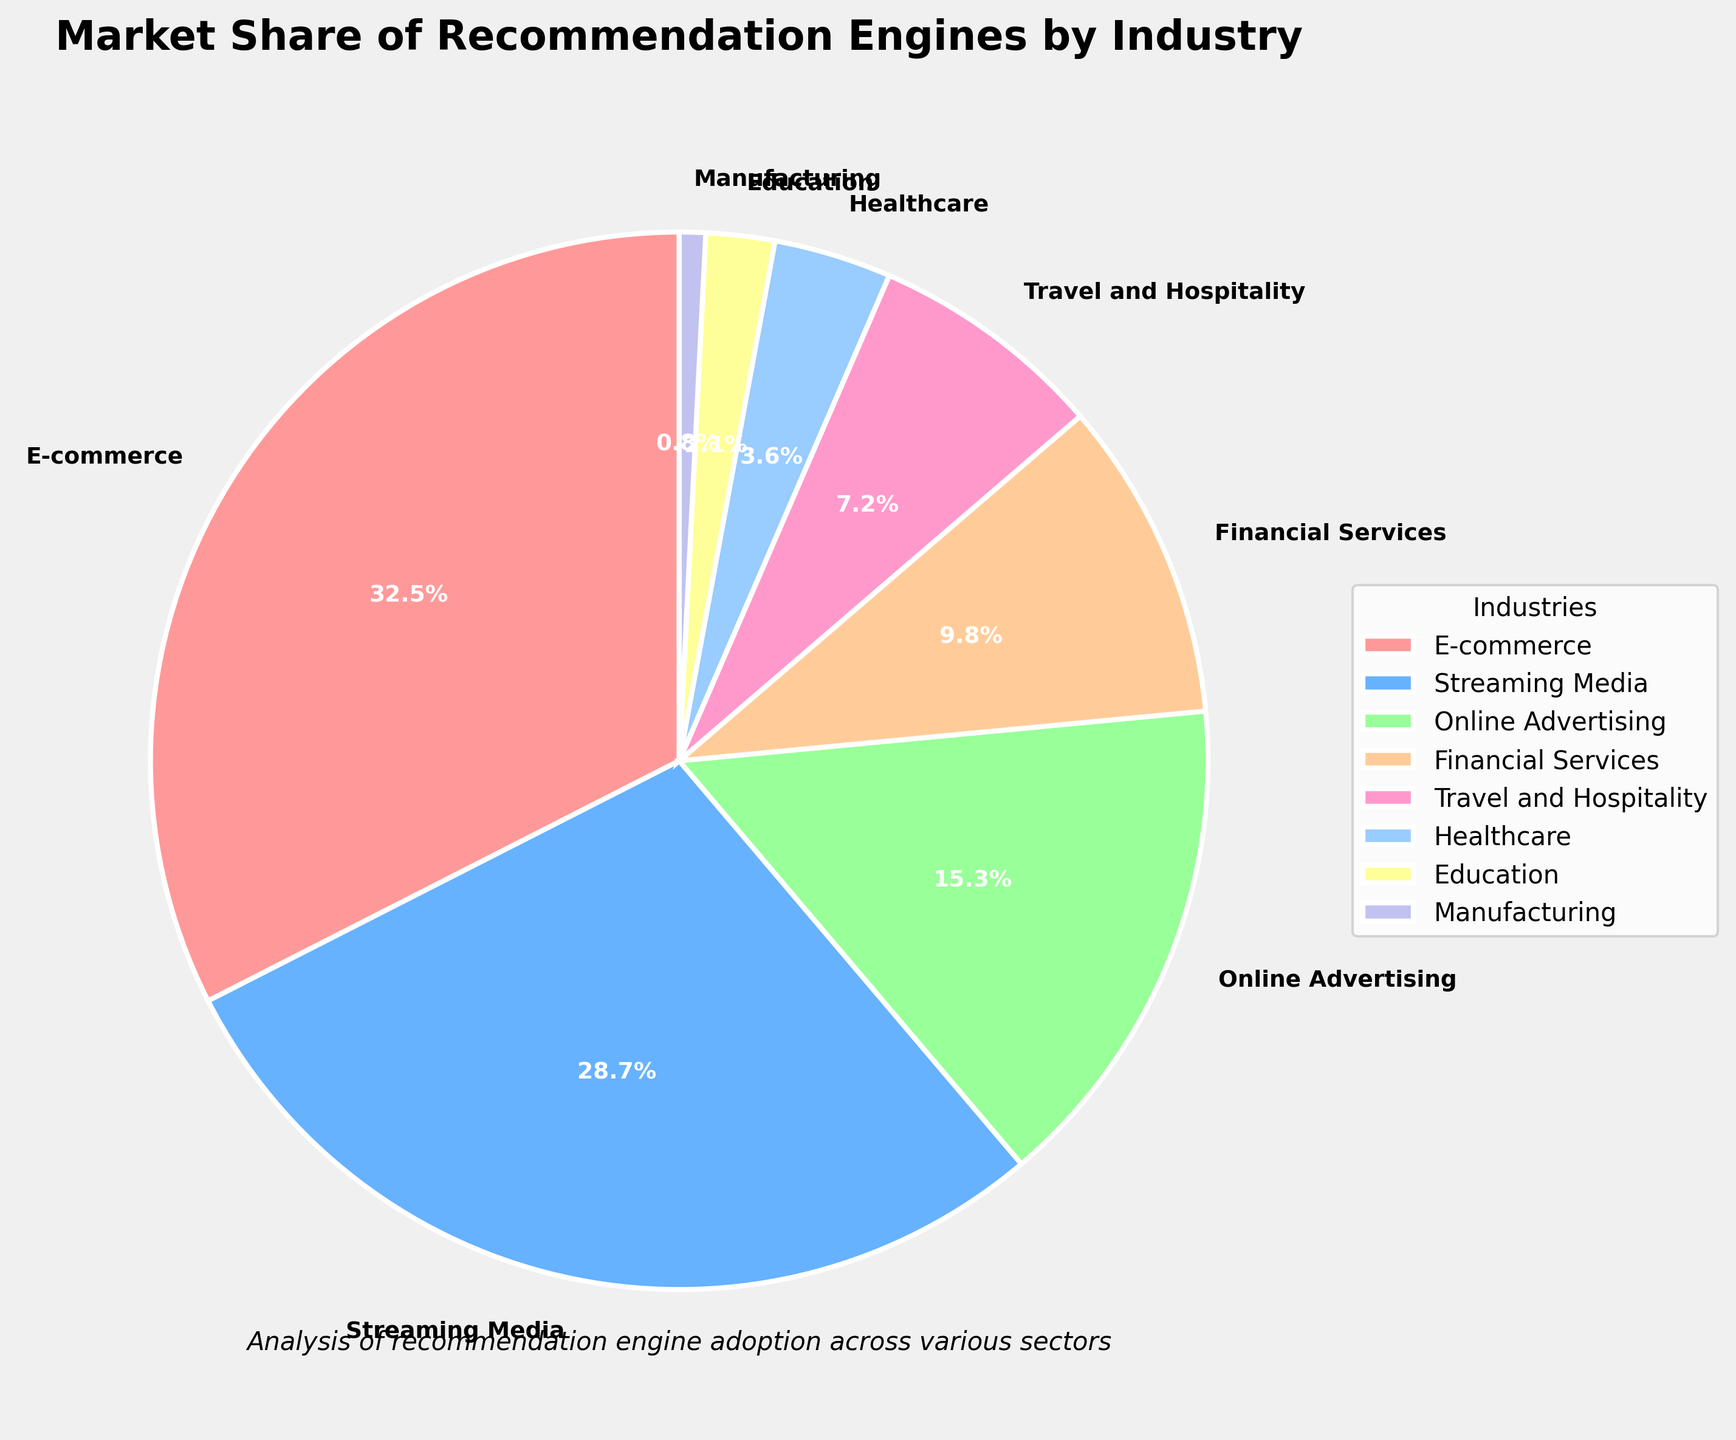Which industry has the highest market share for recommendation engines? By examining the largest segment in the pie chart, we see that the "E-commerce" industry has the highest market share of 32.5%.
Answer: E-commerce Which two industries combined have approximately 45% of the market share? "E-commerce" has 32.5% and "Financial Services" has 9.8%. Summing these, 32.5% + 9.8% = 42.3%, which is close to 45%.
Answer: E-commerce and Financial Services What is the difference in market share between the Streaming Media and Healthcare industries? The market share for "Streaming Media" is 28.7% and for "Healthcare" is 3.6%. The difference is 28.7% - 3.6% = 25.1%.
Answer: 25.1% Which industry has a market share between 5% and 10%? By inspecting the pie chart, "Travel and Hospitality" has a market share of 7.2%, which falls between 5% and 10%.
Answer: Travel and Hospitality Which industry occupies the smallest segment in the pie chart? The smallest segment in the pie chart represents the "Manufacturing" industry with a market share of 0.8%.
Answer: Manufacturing What is the total market share for industries that have less than 10% market share each? The industries are "Financial Services" with 9.8%, "Travel and Hospitality" with 7.2%, "Healthcare" with 3.6%, "Education" with 2.1%, and "Manufacturing" with 0.8%. Adding them up, 9.8% + 7.2% + 3.6% + 2.1% + 0.8% = 23.5%.
Answer: 23.5% Which industry has a market share closest to the overall average market share? First, calculate the average market share by summing all shares and dividing by the number of industries: (32.5 + 28.7 + 15.3 + 9.8 + 7.2 + 3.6 + 2.1 + 0.8)/8 = 12.75%. "Online Advertising" with 15.3% is closest to this average.
Answer: Online Advertising How much more market share does the E-commerce industry have compared to the combined market share of Healthcare and Education? Healthcare has 3.6% and Education has 2.1%, totaling 3.6% + 2.1% = 5.7%. E-commerce has 32.5%, so the difference is 32.5% - 5.7% = 26.8%.
Answer: 26.8% Which industry uses the red color in the pie chart? By visual inspection of the pie chart segment colors, the industry represented by red is "E-commerce".
Answer: E-commerce 